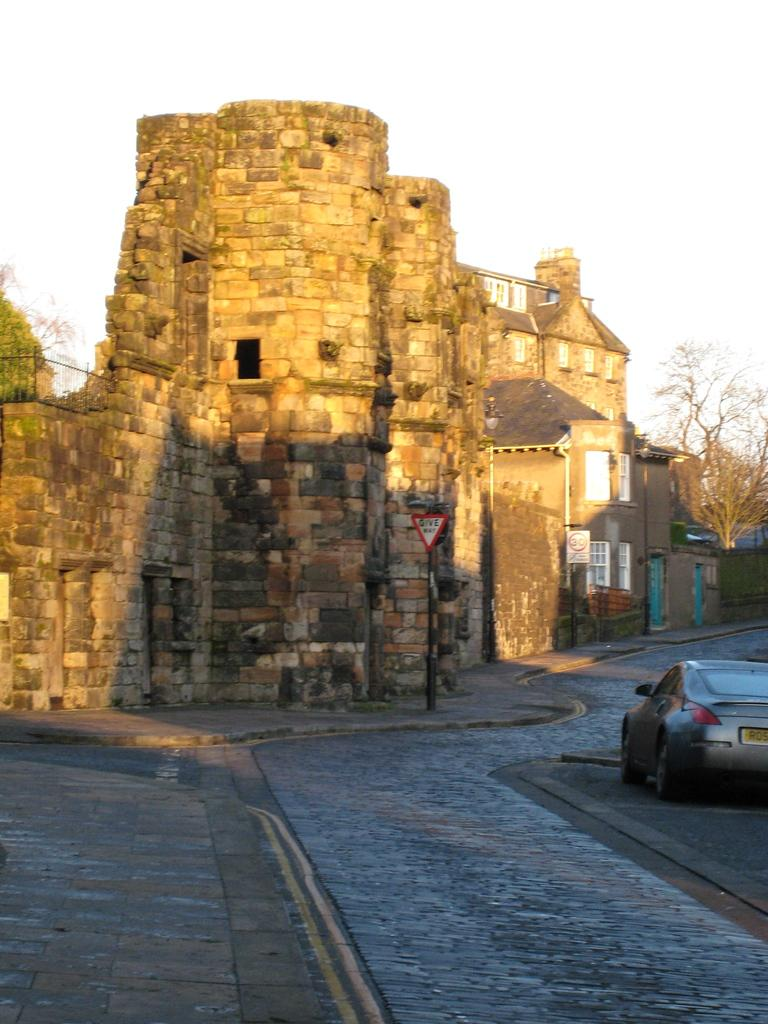What type of structure is depicted in the image? There is a building in the image that resembles a fort. What other natural elements can be seen in the image? There are trees in the image. What man-made object is present on the pavement? There is a sign board on the pavement in the image. What mode of transportation is visible in the image? There is a car on the road in the image. What is visible in the background of the image? The sky is visible in the background of the image. What type of twig is being used as a musical instrument in the image? There is no twig or musical instrument present in the image. What type of tank is visible in the image? There is no tank present in the image. 